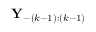<formula> <loc_0><loc_0><loc_500><loc_500>Y _ { - ( k - 1 ) \colon ( k - 1 ) }</formula> 